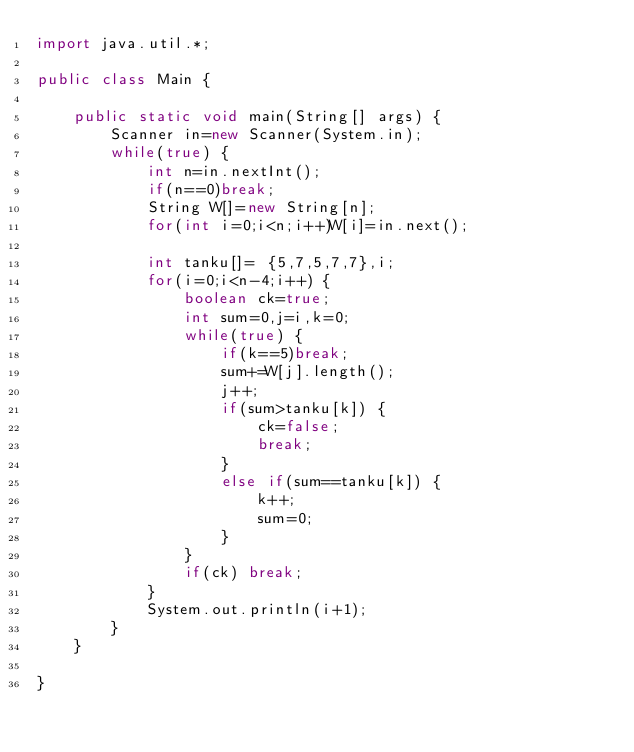Convert code to text. <code><loc_0><loc_0><loc_500><loc_500><_Java_>import java.util.*;

public class Main {

	public static void main(String[] args) {
		Scanner in=new Scanner(System.in);
		while(true) {
			int n=in.nextInt();
			if(n==0)break;
			String W[]=new String[n];
			for(int i=0;i<n;i++)W[i]=in.next();
			
			int tanku[]= {5,7,5,7,7},i;
			for(i=0;i<n-4;i++) {
				boolean ck=true;
				int sum=0,j=i,k=0;
				while(true) {
					if(k==5)break;
					sum+=W[j].length();
					j++;
					if(sum>tanku[k]) {
						ck=false;
						break;
					}
					else if(sum==tanku[k]) {
						k++;
						sum=0;
					}
				}
				if(ck) break;
			}
			System.out.println(i+1);
		}
	}

}

</code> 